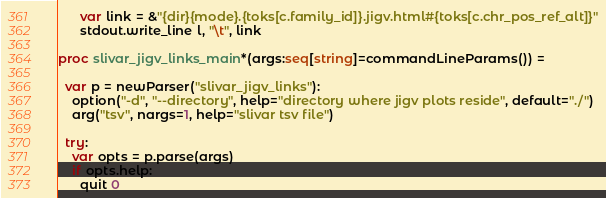<code> <loc_0><loc_0><loc_500><loc_500><_Nim_>      var link = &"{dir}{mode}.{toks[c.family_id]}.jigv.html#{toks[c.chr_pos_ref_alt]}"
      stdout.write_line l, "\t", link

proc slivar_jigv_links_main*(args:seq[string]=commandLineParams()) =

  var p = newParser("slivar_jigv_links"):
    option("-d", "--directory", help="directory where jigv plots reside", default="./")
    arg("tsv", nargs=1, help="slivar tsv file")

  try:
    var opts = p.parse(args)
    if opts.help:
      quit 0
</code> 